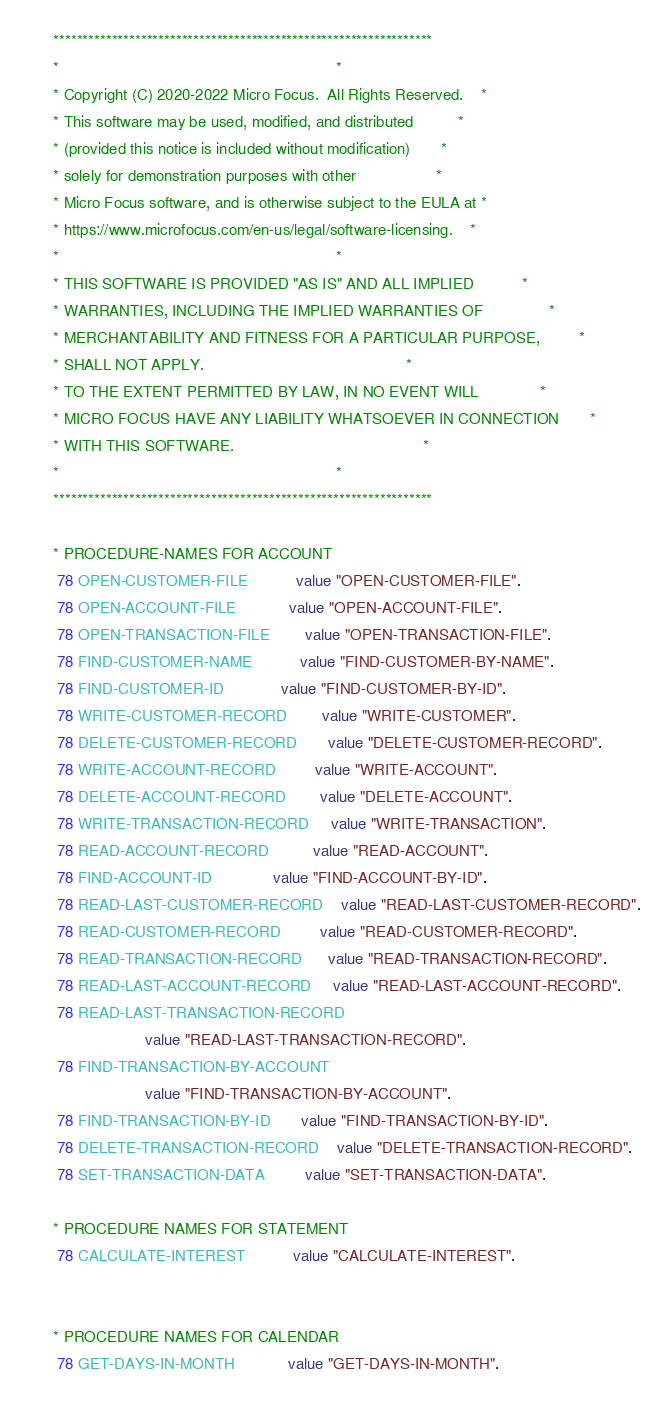Convert code to text. <code><loc_0><loc_0><loc_500><loc_500><_COBOL_>      *****************************************************************
      *                                                               *
      * Copyright (C) 2020-2022 Micro Focus.  All Rights Reserved.    *
      * This software may be used, modified, and distributed          *
      * (provided this notice is included without modification)       *
      * solely for demonstration purposes with other                  *
      * Micro Focus software, and is otherwise subject to the EULA at *
      * https://www.microfocus.com/en-us/legal/software-licensing.    *
      *                                                               *
      * THIS SOFTWARE IS PROVIDED "AS IS" AND ALL IMPLIED           *
      * WARRANTIES, INCLUDING THE IMPLIED WARRANTIES OF               *
      * MERCHANTABILITY AND FITNESS FOR A PARTICULAR PURPOSE,         *
      * SHALL NOT APPLY.                                              *
      * TO THE EXTENT PERMITTED BY LAW, IN NO EVENT WILL              *
      * MICRO FOCUS HAVE ANY LIABILITY WHATSOEVER IN CONNECTION       *
      * WITH THIS SOFTWARE.                                           *
      *                                                               *
      *****************************************************************
      
      * PROCEDURE-NAMES FOR ACCOUNT
       78 OPEN-CUSTOMER-FILE           value "OPEN-CUSTOMER-FILE".
       78 OPEN-ACCOUNT-FILE            value "OPEN-ACCOUNT-FILE".
       78 OPEN-TRANSACTION-FILE        value "OPEN-TRANSACTION-FILE". 
       78 FIND-CUSTOMER-NAME           value "FIND-CUSTOMER-BY-NAME".
       78 FIND-CUSTOMER-ID             value "FIND-CUSTOMER-BY-ID".
       78 WRITE-CUSTOMER-RECORD        value "WRITE-CUSTOMER".
       78 DELETE-CUSTOMER-RECORD       value "DELETE-CUSTOMER-RECORD".
       78 WRITE-ACCOUNT-RECORD         value "WRITE-ACCOUNT".
       78 DELETE-ACCOUNT-RECORD        value "DELETE-ACCOUNT". 
       78 WRITE-TRANSACTION-RECORD     value "WRITE-TRANSACTION".
       78 READ-ACCOUNT-RECORD          value "READ-ACCOUNT". 
       78 FIND-ACCOUNT-ID              value "FIND-ACCOUNT-BY-ID". 
       78 READ-LAST-CUSTOMER-RECORD    value "READ-LAST-CUSTOMER-RECORD". 
       78 READ-CUSTOMER-RECORD         value "READ-CUSTOMER-RECORD". 
       78 READ-TRANSACTION-RECORD      value "READ-TRANSACTION-RECORD".
       78 READ-LAST-ACCOUNT-RECORD     value "READ-LAST-ACCOUNT-RECORD". 
       78 READ-LAST-TRANSACTION-RECORD
                           value "READ-LAST-TRANSACTION-RECORD".
       78 FIND-TRANSACTION-BY-ACCOUNT 
                           value "FIND-TRANSACTION-BY-ACCOUNT". 
       78 FIND-TRANSACTION-BY-ID       value "FIND-TRANSACTION-BY-ID". 
       78 DELETE-TRANSACTION-RECORD    value "DELETE-TRANSACTION-RECORD".
       78 SET-TRANSACTION-DATA         value "SET-TRANSACTION-DATA". 
       
      * PROCEDURE NAMES FOR STATEMENT
       78 CALCULATE-INTEREST           value "CALCULATE-INTEREST". 


      * PROCEDURE NAMES FOR CALENDAR
       78 GET-DAYS-IN-MONTH            value "GET-DAYS-IN-MONTH".


</code> 